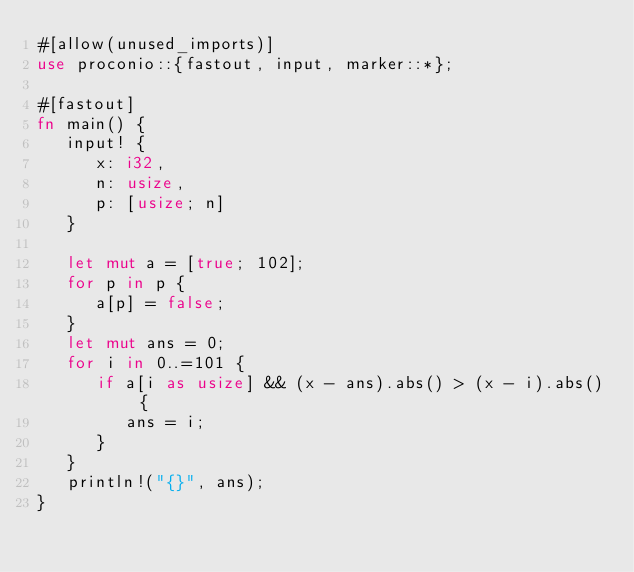<code> <loc_0><loc_0><loc_500><loc_500><_Rust_>#[allow(unused_imports)]
use proconio::{fastout, input, marker::*};

#[fastout]
fn main() {
   input! {
      x: i32,
      n: usize,
      p: [usize; n]
   }

   let mut a = [true; 102];
   for p in p {
      a[p] = false;
   }
   let mut ans = 0;
   for i in 0..=101 {
      if a[i as usize] && (x - ans).abs() > (x - i).abs() {
         ans = i;
      }
   }
   println!("{}", ans);
}
</code> 